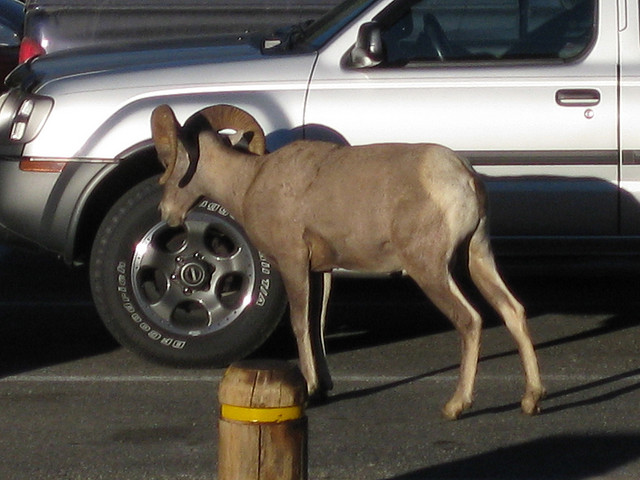Can you tell where this animal is located? The donkey is in a parking lot, given the presence of parked cars and demarcation poles. 